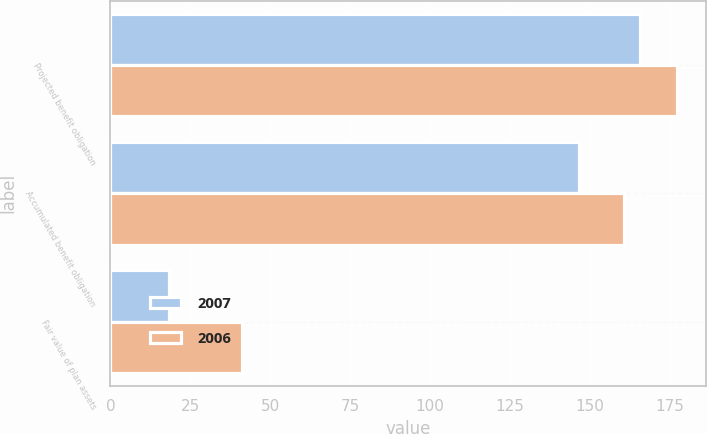Convert chart to OTSL. <chart><loc_0><loc_0><loc_500><loc_500><stacked_bar_chart><ecel><fcel>Projected benefit obligation<fcel>Accumulated benefit obligation<fcel>Fair value of plan assets<nl><fcel>2007<fcel>165.7<fcel>146.8<fcel>18.3<nl><fcel>2006<fcel>177.4<fcel>160.6<fcel>41.3<nl></chart> 